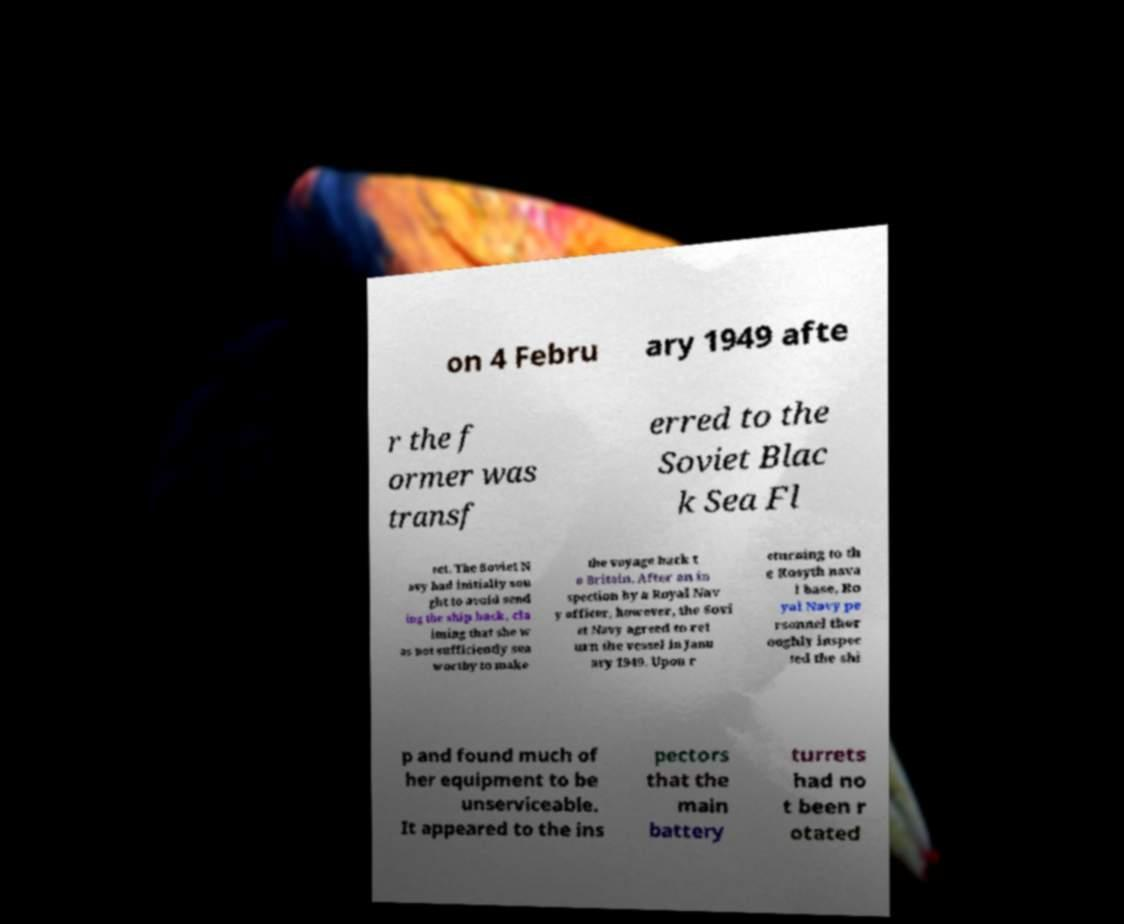Could you assist in decoding the text presented in this image and type it out clearly? on 4 Febru ary 1949 afte r the f ormer was transf erred to the Soviet Blac k Sea Fl eet. The Soviet N avy had initially sou ght to avoid send ing the ship back, cla iming that she w as not sufficiently sea worthy to make the voyage back t o Britain. After an in spection by a Royal Nav y officer, however, the Sovi et Navy agreed to ret urn the vessel in Janu ary 1949. Upon r eturning to th e Rosyth nava l base, Ro yal Navy pe rsonnel thor oughly inspec ted the shi p and found much of her equipment to be unserviceable. It appeared to the ins pectors that the main battery turrets had no t been r otated 